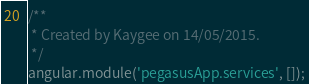<code> <loc_0><loc_0><loc_500><loc_500><_JavaScript_>/**
 * Created by Kaygee on 14/05/2015.
 */
angular.module('pegasusApp.services', []);</code> 